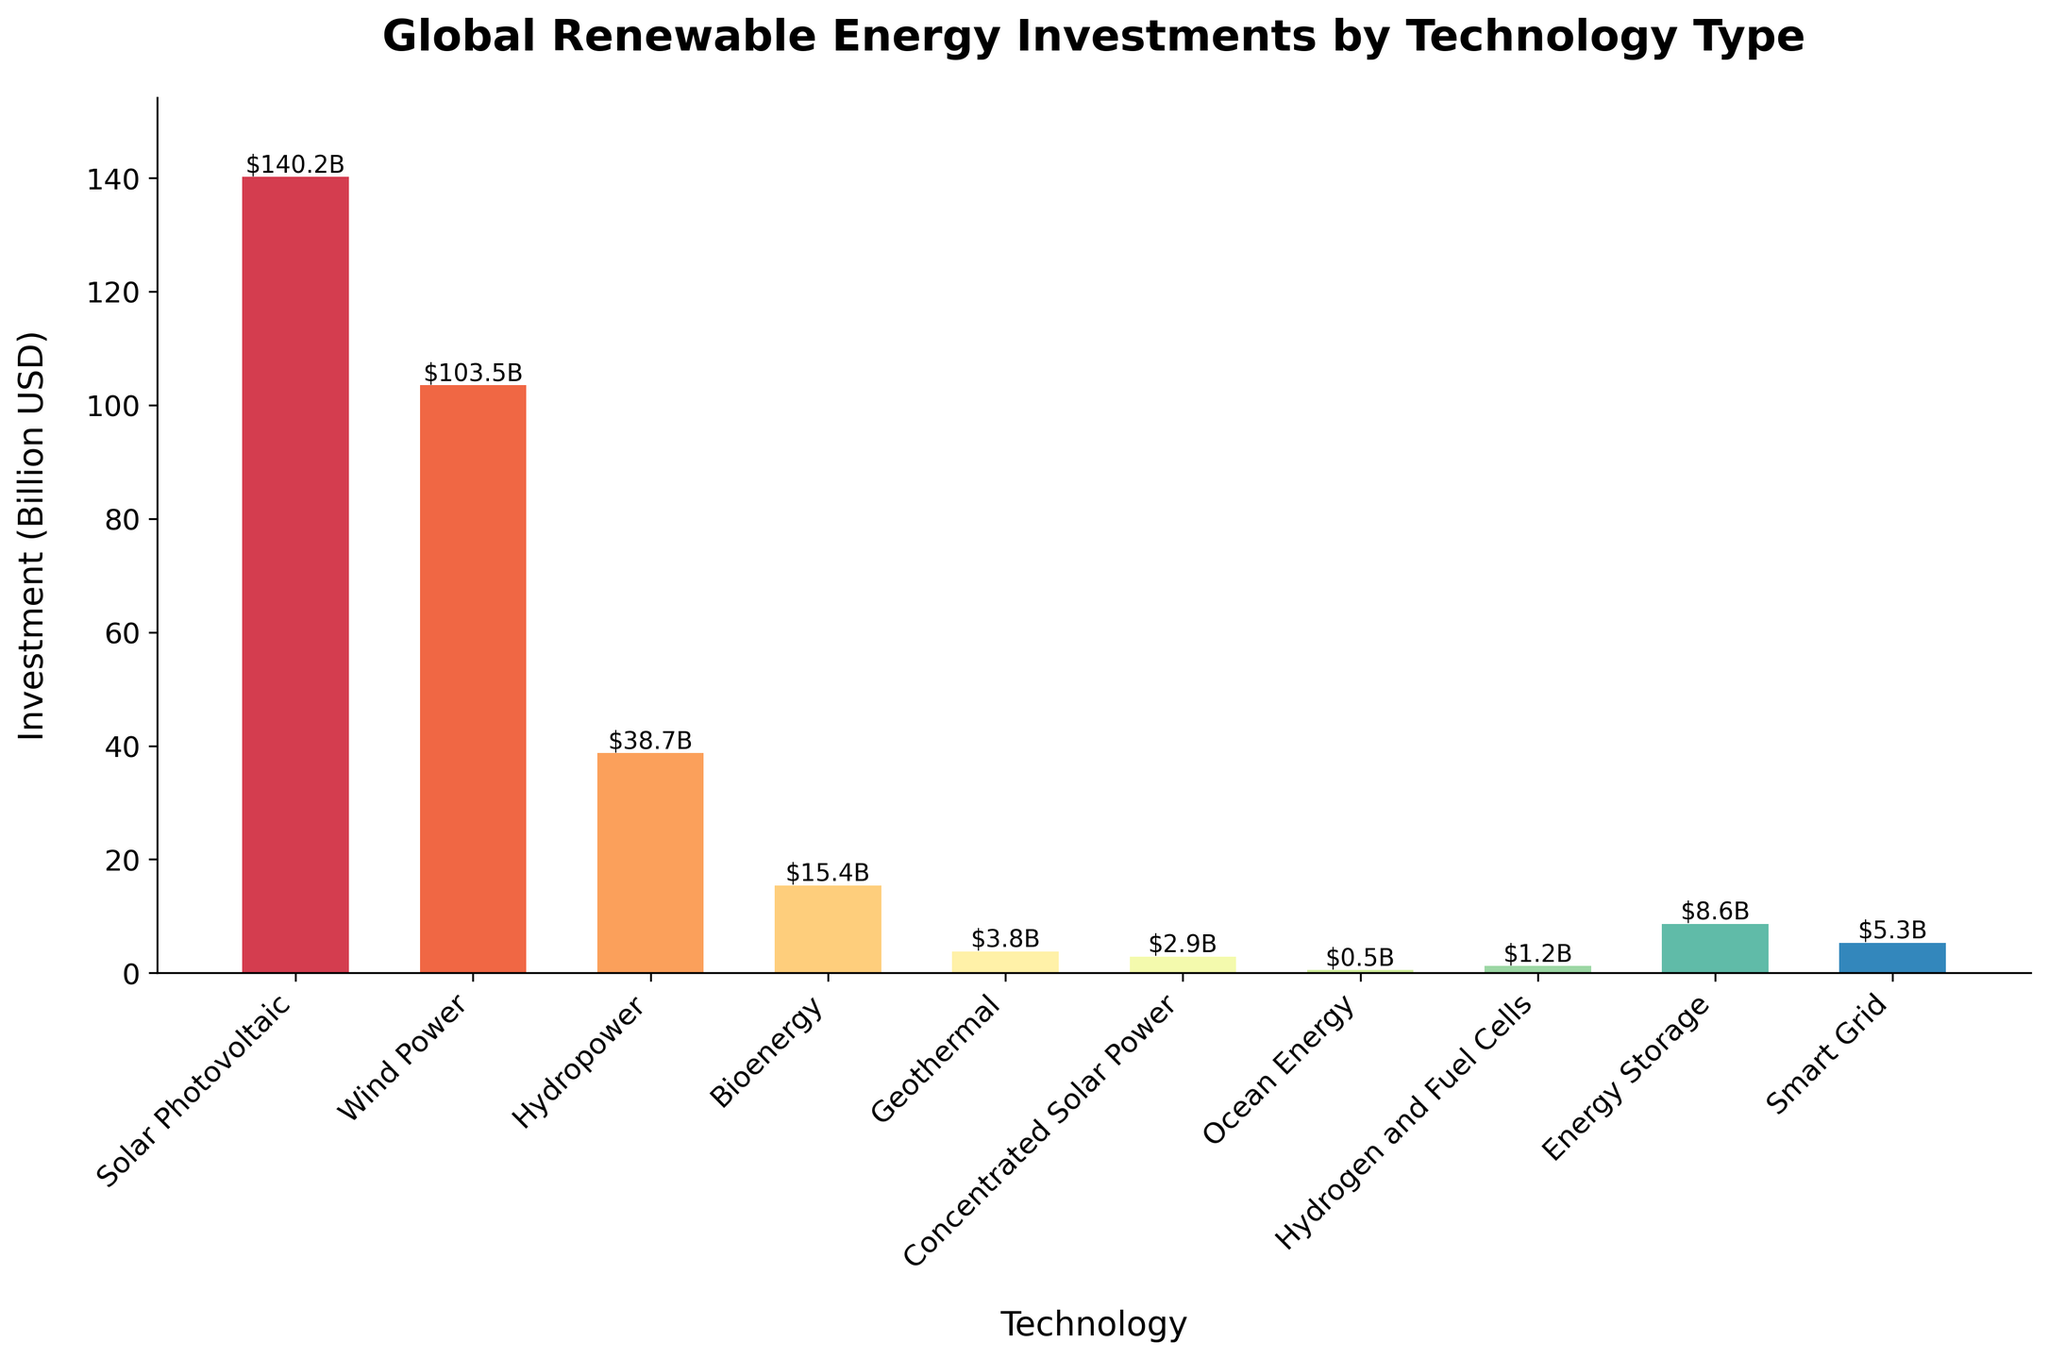What technology received the highest investment in renewable energy? By comparing the height of the bars, it is clear that Solar Photovoltaic has the highest bar, indicating that it received the highest investment among the listed technologies.
Answer: Solar Photovoltaic How much more was invested in Solar Photovoltaic compared to Wind Power? Solar Photovoltaic received $140.2 billion, and Wind Power received $103.5 billion. Subtracting these values gives $140.2 billion - $103.5 billion = $36.7 billion.
Answer: $36.7 billion What is the combined investment in Hydropower, Bioenergy, and Geothermal? Summing the investments for Hydropower ($38.7 billion), Bioenergy ($15.4 billion), and Geothermal ($3.8 billion) gives: $38.7B + $15.4B + $3.8B = $57.9 billion.
Answer: $57.9 billion Is the investment in Energy Storage higher than in Smart Grid? Comparing the heights of the bars, Energy Storage ($8.6 billion) has a higher bar than Smart Grid ($5.3 billion), indicating higher investment.
Answer: Yes What percentage of the total investment was allocated to Wind Power? Adding up all investments gives a total: $140.2B (Solar Photovoltaic) + $103.5B (Wind Power) + $38.7B (Hydropower) + $15.4B (Bioenergy) + $3.8B (Geothermal) + $2.9B (Concentrated Solar Power) + $0.5B (Ocean Energy) + $1.2B (Hydrogen and Fuel Cells) + $8.6B (Energy Storage) + $5.3B (Smart Grid) = $320.1 billion.
Then calculate Wind Power's percentage: ($103.5B / $320.1B) * 100 ≈ 32.3%.
Answer: 32.3% Which technology had the second-lowest investment? By examining the bar heights from smallest to largest, the second-lowest bar is Hydrogen and Fuel Cells, with an investment of $1.2 billion.
Answer: Hydrogen and Fuel Cells What is the average investment across all listed technologies? Sum all investments ($320.1 billion) and divide by the number of technologies (10): $320.1 billion / 10 = $32.01 billion.
Answer: $32.01 billion How does the investment in Solar Photovoltaic compare to the total investment in all other technologies combined? Calculate the total investment in other technologies by subtracting Solar Photovoltaic's investment from the total: $320.1 billion - $140.2 billion = $179.9 billion. Solar Photovoltaic's investment of $140.2 billion is less than the combined total of other technologies.
Answer: Less Which technologies have an investment below $5 billion? Technologies with investments below $5 billion are identified by shorter bars: Geothermal ($3.8 billion), Concentrated Solar Power ($2.9 billion), Ocean Energy ($0.5 billion), and Hydrogen and Fuel Cells ($1.2 billion).
Answer: Geothermal, Concentrated Solar Power, Ocean Energy, Hydrogen and Fuel Cells 